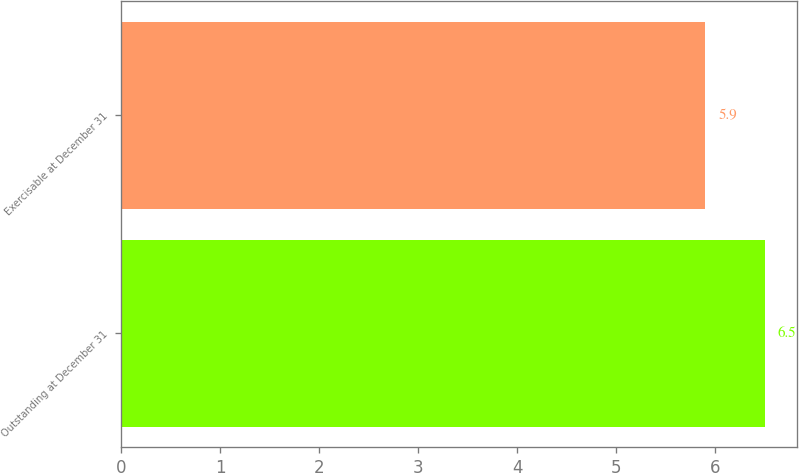Convert chart. <chart><loc_0><loc_0><loc_500><loc_500><bar_chart><fcel>Outstanding at December 31<fcel>Exercisable at December 31<nl><fcel>6.5<fcel>5.9<nl></chart> 